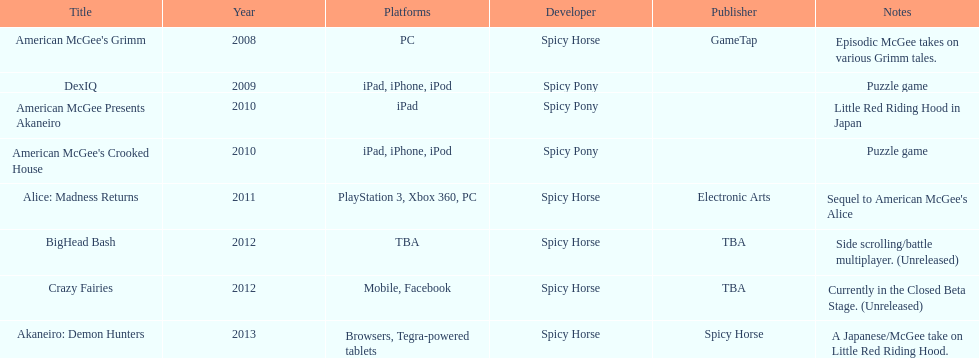Give me the full table as a dictionary. {'header': ['Title', 'Year', 'Platforms', 'Developer', 'Publisher', 'Notes'], 'rows': [["American McGee's Grimm", '2008', 'PC', 'Spicy Horse', 'GameTap', 'Episodic McGee takes on various Grimm tales.'], ['DexIQ', '2009', 'iPad, iPhone, iPod', 'Spicy Pony', '', 'Puzzle game'], ['American McGee Presents Akaneiro', '2010', 'iPad', 'Spicy Pony', '', 'Little Red Riding Hood in Japan'], ["American McGee's Crooked House", '2010', 'iPad, iPhone, iPod', 'Spicy Pony', '', 'Puzzle game'], ['Alice: Madness Returns', '2011', 'PlayStation 3, Xbox 360, PC', 'Spicy Horse', 'Electronic Arts', "Sequel to American McGee's Alice"], ['BigHead Bash', '2012', 'TBA', 'Spicy Horse', 'TBA', 'Side scrolling/battle multiplayer. (Unreleased)'], ['Crazy Fairies', '2012', 'Mobile, Facebook', 'Spicy Horse', 'TBA', 'Currently in the Closed Beta Stage. (Unreleased)'], ['Akaneiro: Demon Hunters', '2013', 'Browsers, Tegra-powered tablets', 'Spicy Horse', 'Spicy Horse', 'A Japanese/McGee take on Little Red Riding Hood.']]} What is the total number of games developed by spicy horse? 5. 